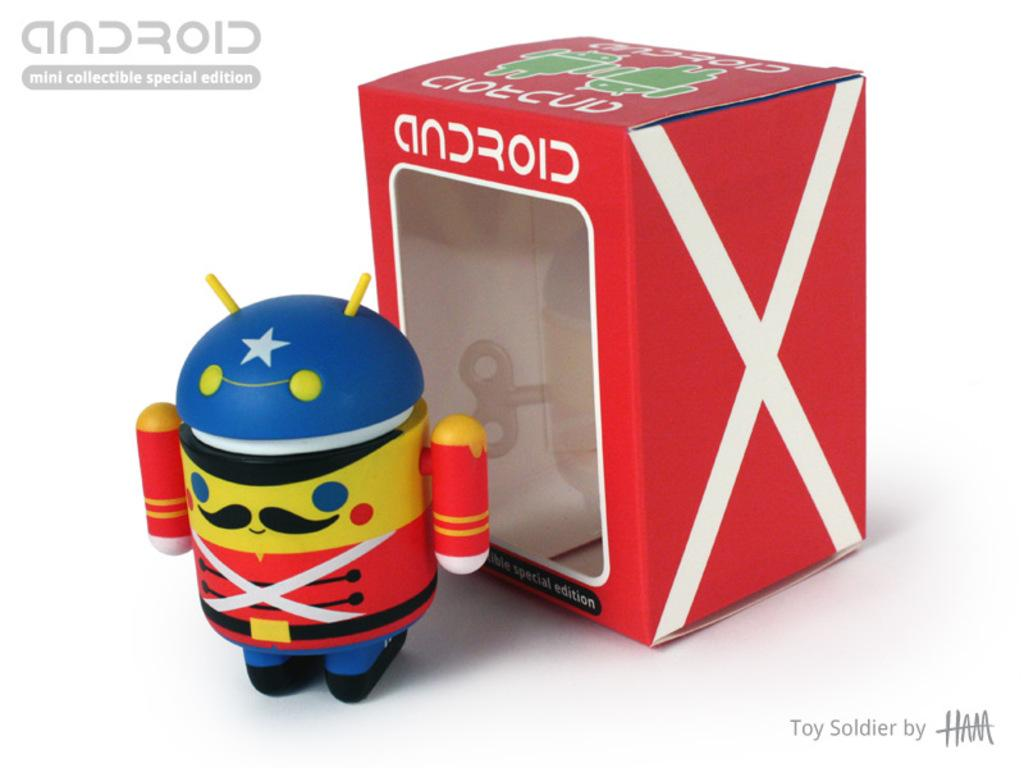What type of toy is in the image? There is an android toy in the image. Can you describe the packaging of the toy? There is a box of the toy behind the toy in the image. How does the android toy expand in the image? The android toy does not expand in the image; it is a static toy. 